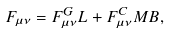<formula> <loc_0><loc_0><loc_500><loc_500>F _ { \mu \nu } = F _ { \mu \nu } ^ { G } L + F _ { \mu \nu } ^ { C } M B ,</formula> 